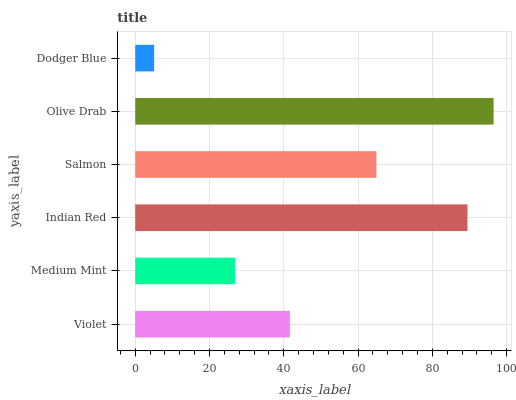Is Dodger Blue the minimum?
Answer yes or no. Yes. Is Olive Drab the maximum?
Answer yes or no. Yes. Is Medium Mint the minimum?
Answer yes or no. No. Is Medium Mint the maximum?
Answer yes or no. No. Is Violet greater than Medium Mint?
Answer yes or no. Yes. Is Medium Mint less than Violet?
Answer yes or no. Yes. Is Medium Mint greater than Violet?
Answer yes or no. No. Is Violet less than Medium Mint?
Answer yes or no. No. Is Salmon the high median?
Answer yes or no. Yes. Is Violet the low median?
Answer yes or no. Yes. Is Olive Drab the high median?
Answer yes or no. No. Is Indian Red the low median?
Answer yes or no. No. 